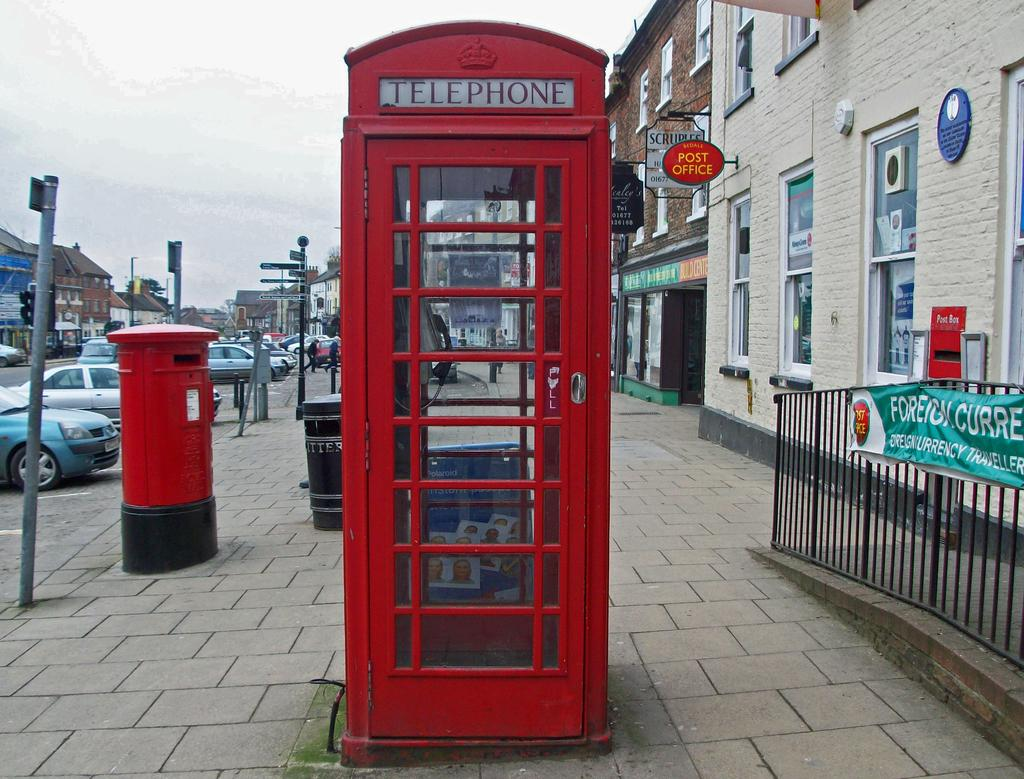<image>
Give a short and clear explanation of the subsequent image. A red telephone box sitting on a thoroughfare. 